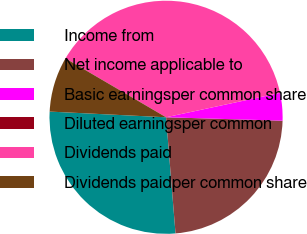<chart> <loc_0><loc_0><loc_500><loc_500><pie_chart><fcel>Income from<fcel>Net income applicable to<fcel>Basic earningsper common share<fcel>Diluted earningsper common<fcel>Dividends paid<fcel>Dividends paidper common share<nl><fcel>27.07%<fcel>23.24%<fcel>3.82%<fcel>0.0%<fcel>38.22%<fcel>7.65%<nl></chart> 